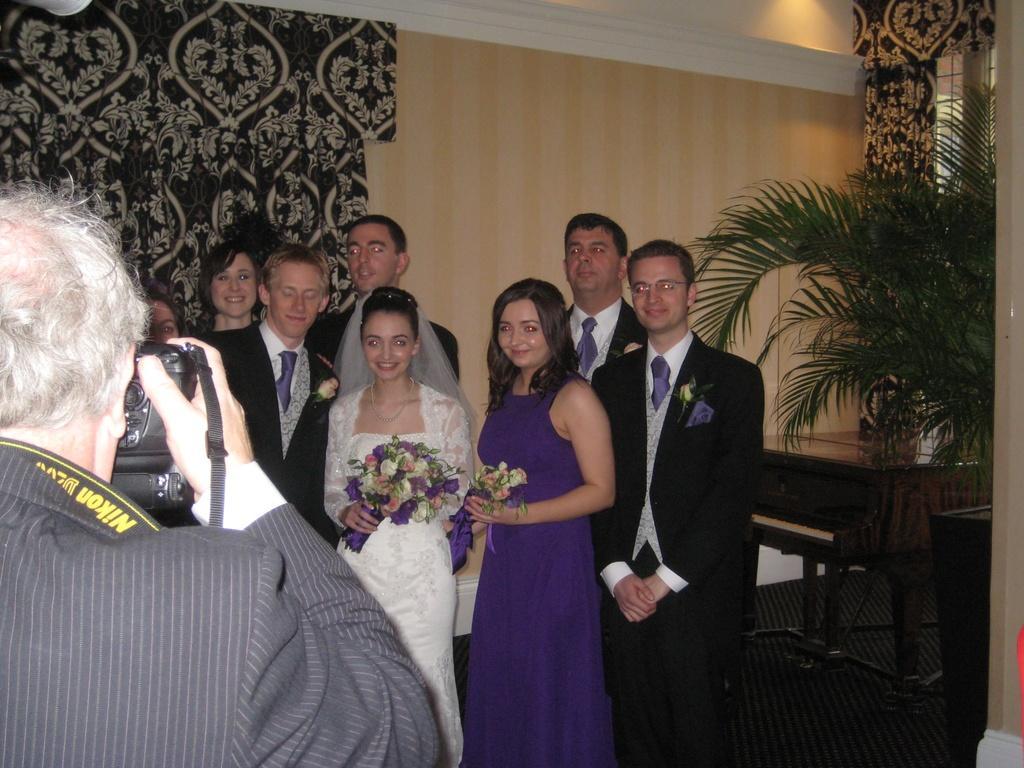In one or two sentences, can you explain what this image depicts? In the picture I can see a group of people are standing among them the man in the front is holding a camera in the hand and two women are holding flowers in hands. In the background I can see plants, a wall, a table and some other objects. 